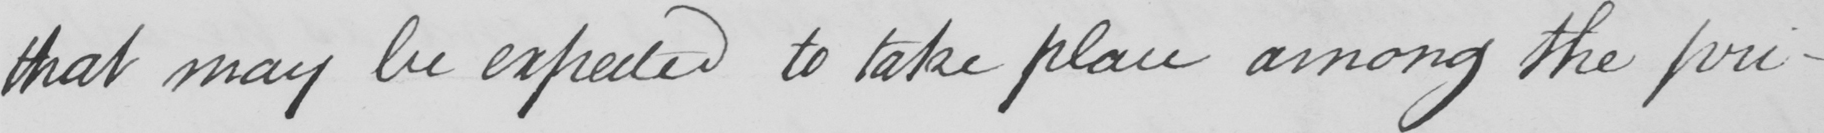Transcribe the text shown in this historical manuscript line. that may be expected to take place among the pri- 